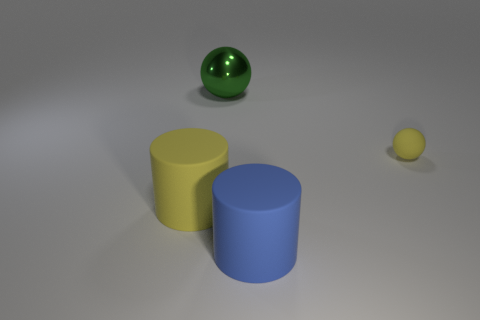How big is the rubber object that is right of the big matte thing on the right side of the green shiny sphere?
Provide a succinct answer. Small. What number of large objects are green metallic balls or blue matte cylinders?
Give a very brief answer. 2. There is a yellow rubber object that is behind the rubber cylinder that is on the left side of the matte cylinder in front of the yellow rubber cylinder; how big is it?
Ensure brevity in your answer.  Small. Is there anything else that is the same color as the large sphere?
Give a very brief answer. No. What material is the ball left of the big rubber object that is to the right of the large object that is behind the small ball made of?
Offer a very short reply. Metal. Do the small object and the big metal object have the same shape?
Your answer should be compact. Yes. Is there anything else that is the same material as the green thing?
Keep it short and to the point. No. What number of big things are both on the left side of the large blue matte object and in front of the large metal thing?
Make the answer very short. 1. What color is the cylinder behind the object that is in front of the large yellow rubber object?
Make the answer very short. Yellow. Are there the same number of big matte cylinders behind the large yellow matte object and blue matte things?
Offer a terse response. No. 